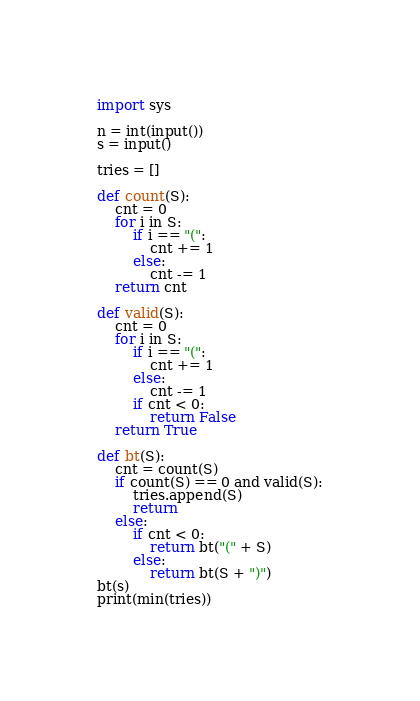<code> <loc_0><loc_0><loc_500><loc_500><_Python_>import sys

n = int(input())
s = input()

tries = []

def count(S):
    cnt = 0
    for i in S:
        if i == "(":
            cnt += 1
        else:
            cnt -= 1
    return cnt

def valid(S):
    cnt = 0
    for i in S:
        if i == "(":
            cnt += 1
        else:
            cnt -= 1
        if cnt < 0:
            return False
    return True

def bt(S):
    cnt = count(S)
    if count(S) == 0 and valid(S):
        tries.append(S)
        return
    else:
        if cnt < 0:
            return bt("(" + S)
        else:
            return bt(S + ")")
bt(s)
print(min(tries))
</code> 